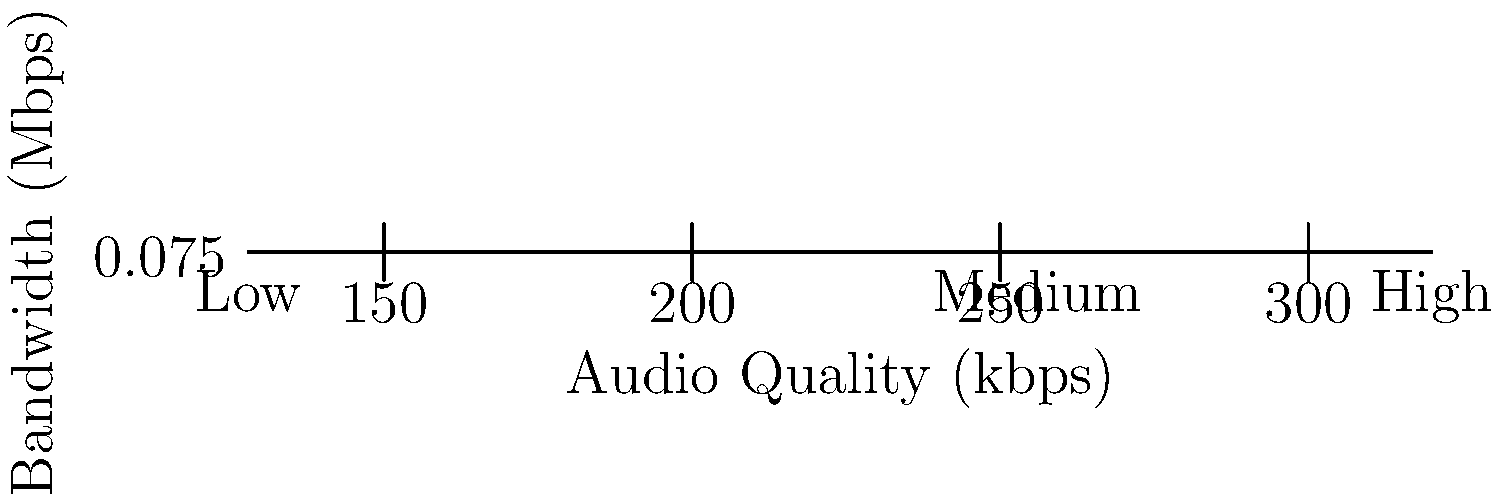As a musician with a speech disorder, you're exploring online streaming platforms to share your music. The graph shows bandwidth requirements for different audio quality levels. If your target audience has an average internet speed of 10 Mbps, what's the highest audio quality you can consistently offer without buffering issues, assuming you want to use no more than 2% of their bandwidth? To solve this problem, we'll follow these steps:

1. Calculate the available bandwidth:
   $10 \text{ Mbps} \times 2\% = 0.2 \text{ Mbps}$

2. Examine the graph to find the highest quality that requires less than 0.2 Mbps:
   - Low quality (128 kbps): 0.0576 Mbps
   - Medium quality (256 kbps): 0.1152 Mbps
   - High quality (320 kbps): 0.144 Mbps

3. The highest quality that stays below 0.2 Mbps is the high quality option at 320 kbps, which requires 0.144 Mbps.

Therefore, you can consistently offer the highest audio quality (320 kbps) without causing buffering issues for your audience.
Answer: 320 kbps 